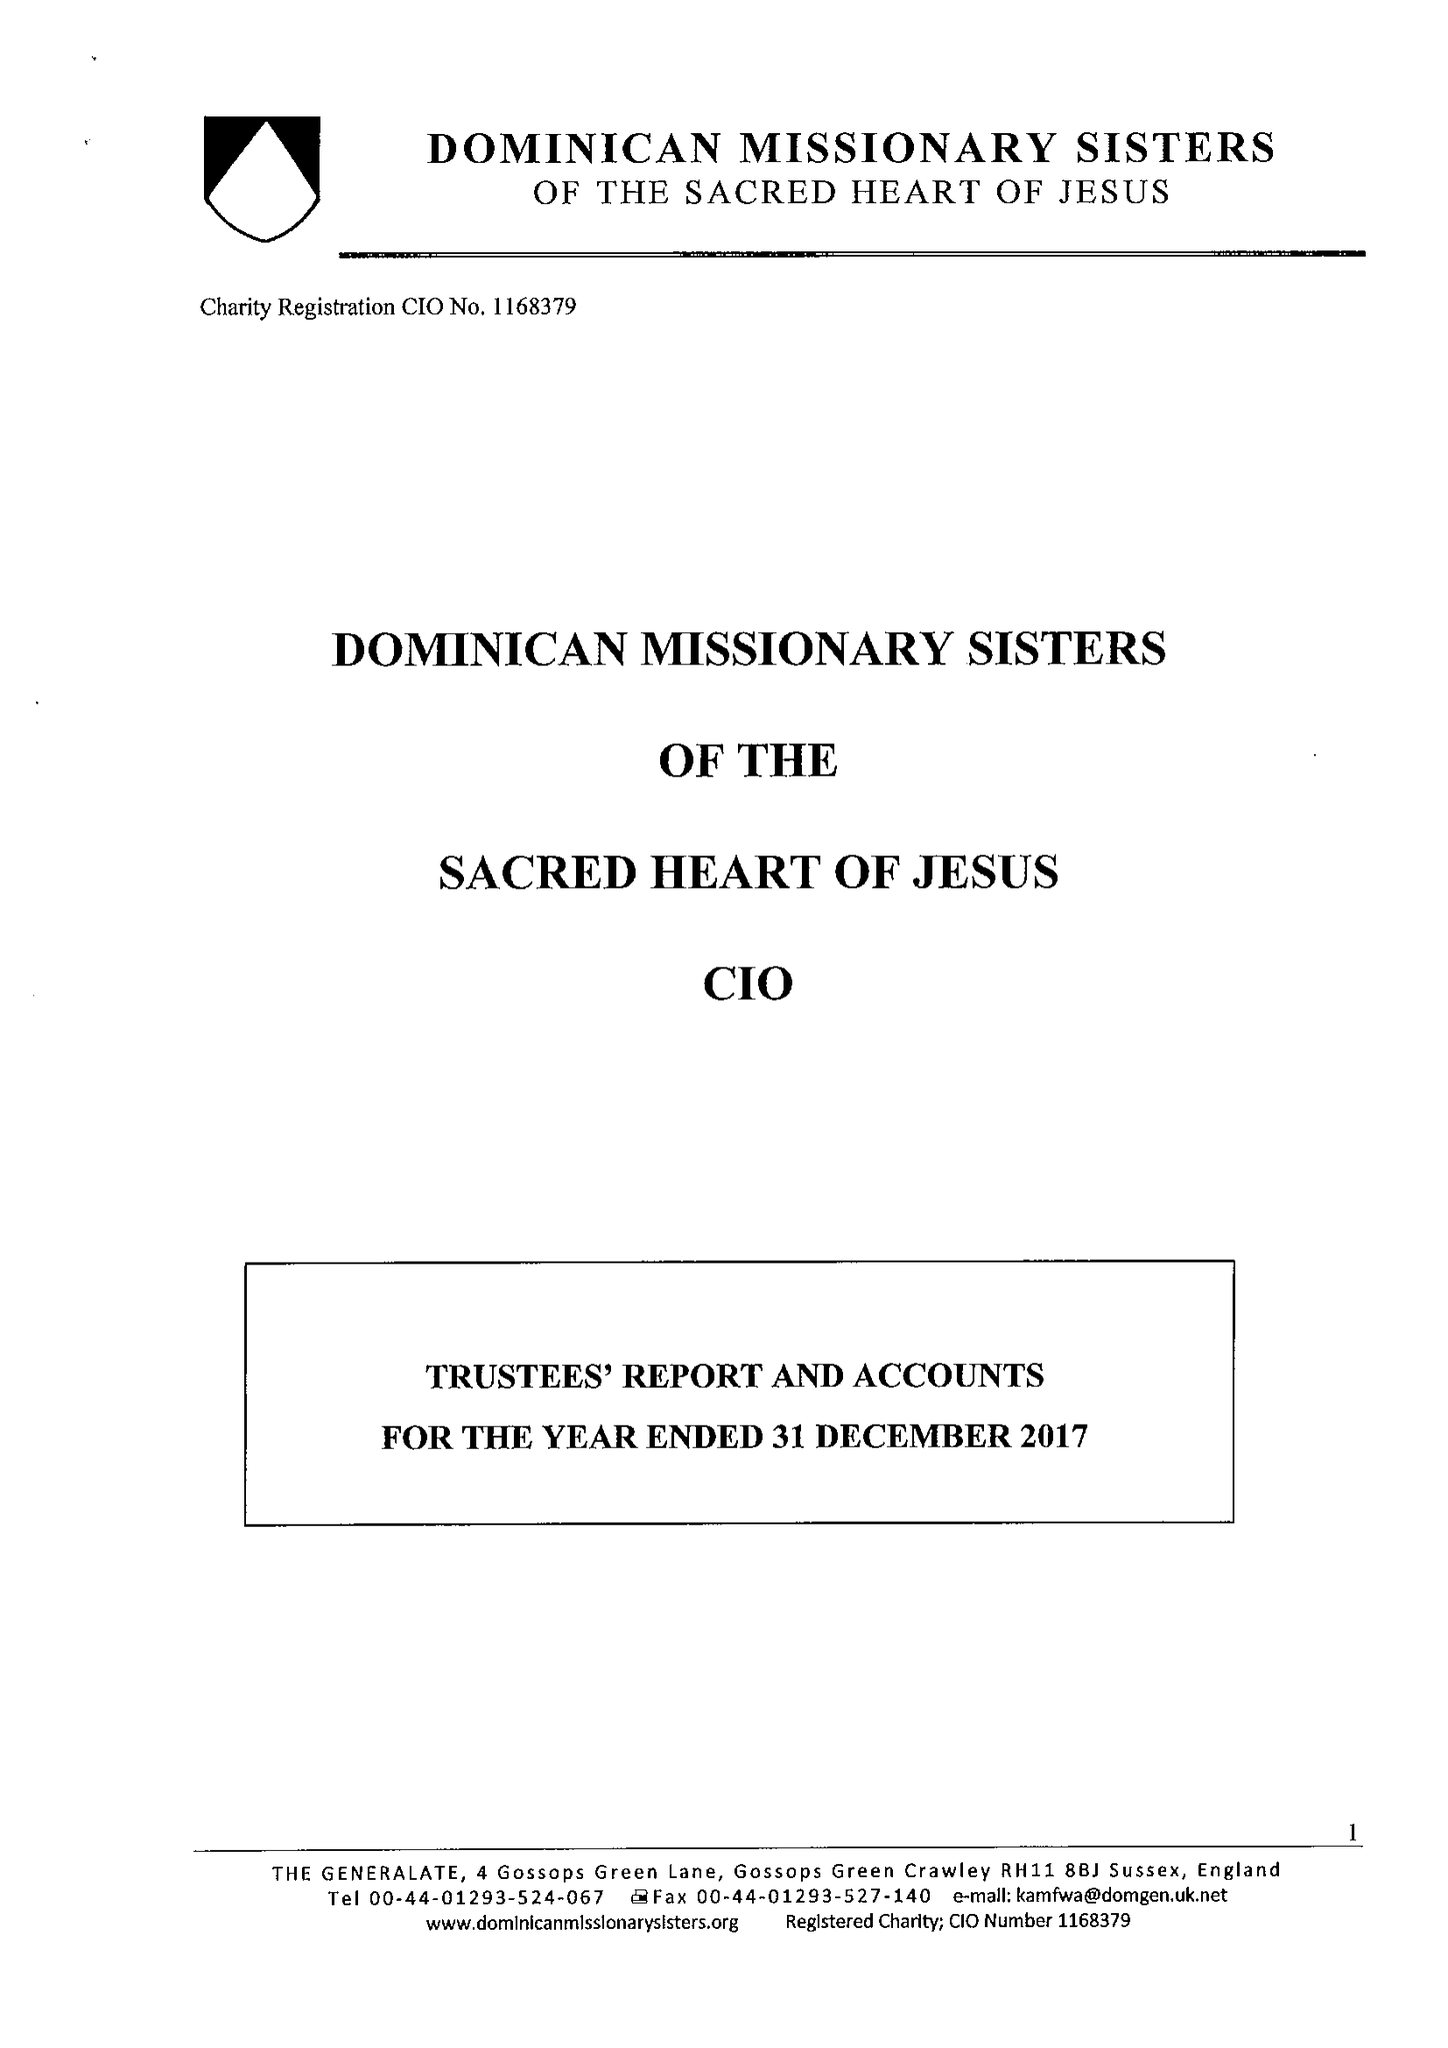What is the value for the report_date?
Answer the question using a single word or phrase. 2017-12-31 